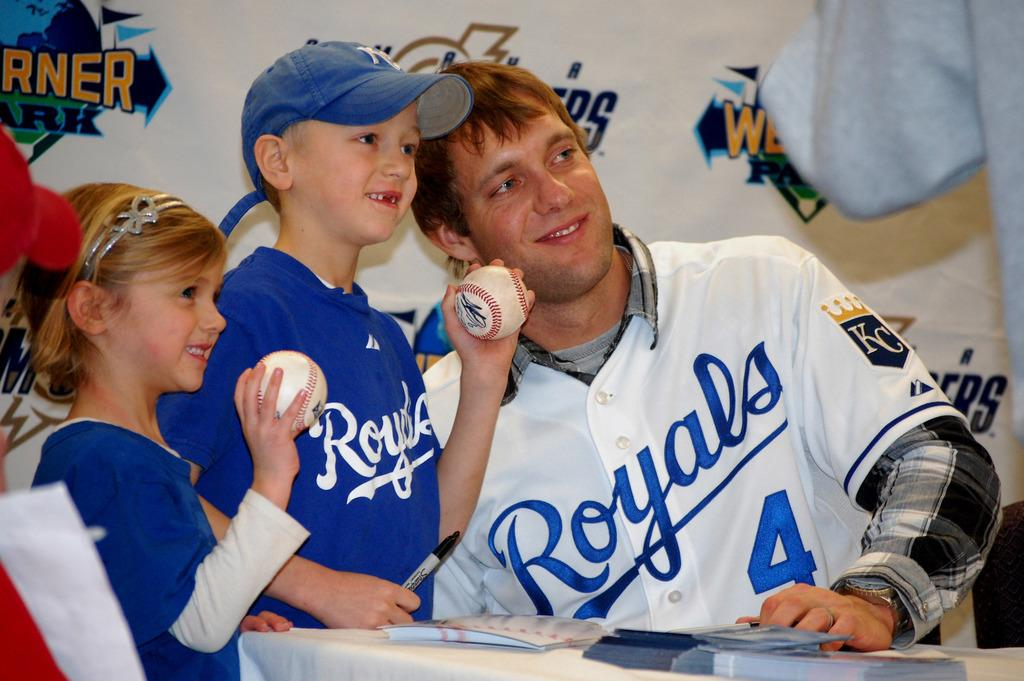<image>
Provide a brief description of the given image. a Royals player posing with some other kids that are there 